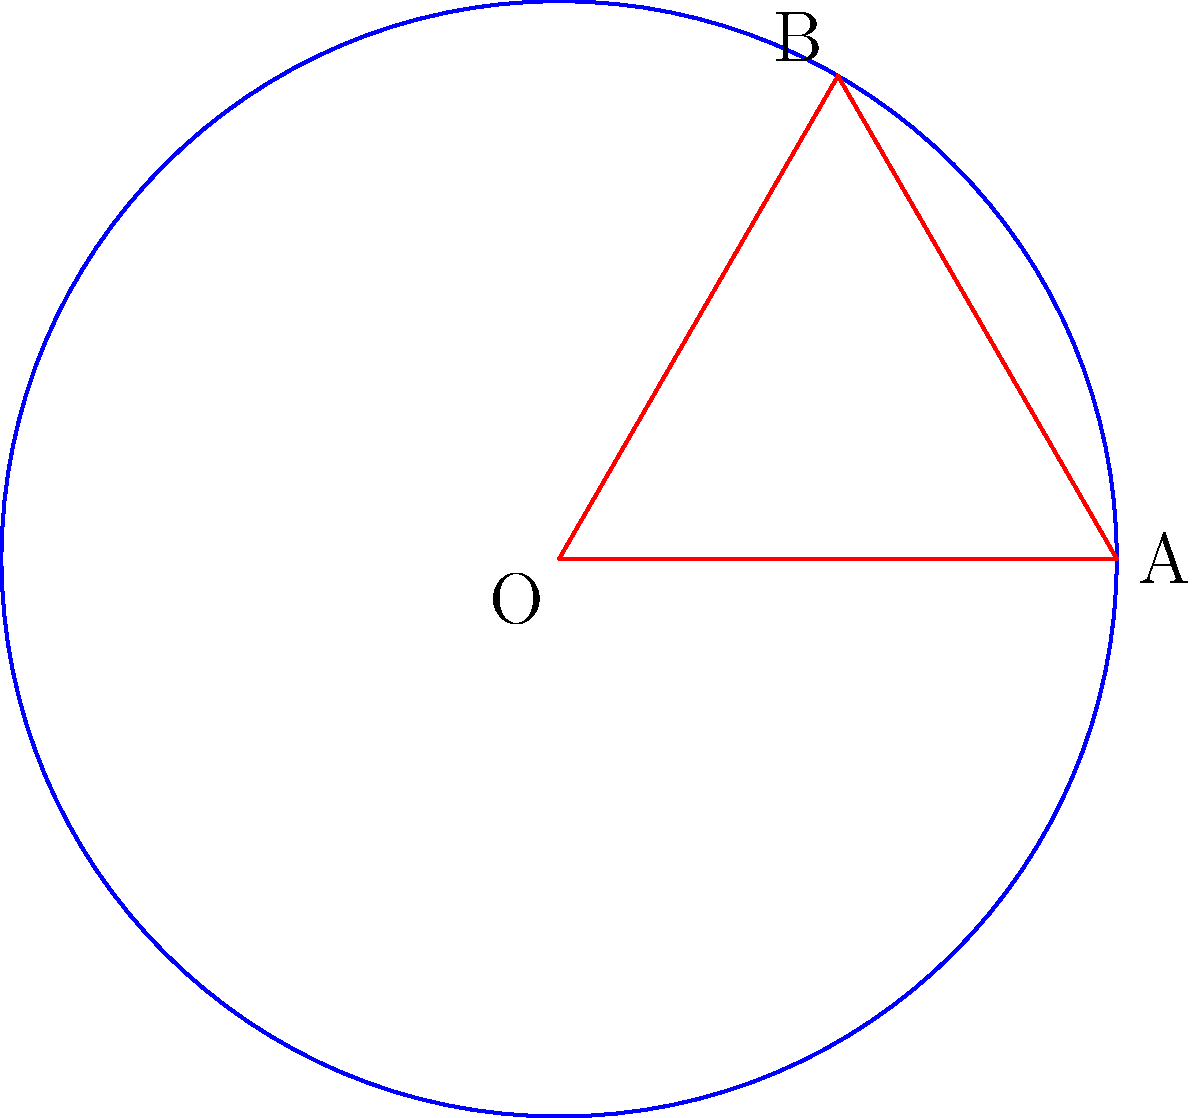In a non-Euclidean geometry on a motorcycle-inspired curved space, the area of a circle is given by $A = 4\pi \sinh^2(r/2)$, where $r$ is the radius. If the radius of a non-Euclidean circle is equal to the radius of your dream sports bike's wheel, which is 18 inches, calculate the difference between the areas of the non-Euclidean circle and a regular Euclidean circle with the same radius. Round your answer to the nearest square inch. Let's approach this step-by-step:

1) First, we need to calculate the area of the non-Euclidean circle:
   $A_{non-Euclidean} = 4\pi \sinh^2(r/2)$
   $r = 18$ inches
   $A_{non-Euclidean} = 4\pi \sinh^2(18/2) = 4\pi \sinh^2(9)$

2) Calculate $\sinh(9)$:
   $\sinh(9) \approx 4,051.54$

3) Now we can calculate the non-Euclidean area:
   $A_{non-Euclidean} = 4\pi (4,051.54)^2 \approx 205,887,658$ sq inches

4) Next, calculate the area of a regular Euclidean circle:
   $A_{Euclidean} = \pi r^2 = \pi (18)^2 = 324\pi \approx 1,018$ sq inches

5) Find the difference:
   $Difference = A_{non-Euclidean} - A_{Euclidean}$
   $= 205,887,658 - 1,018 = 205,886,640$ sq inches

6) Rounding to the nearest square inch:
   $205,886,640$ sq inches

The difference is much larger than a typical motorcycle wheel due to the extreme curvature in non-Euclidean space.
Answer: 205,886,640 square inches 